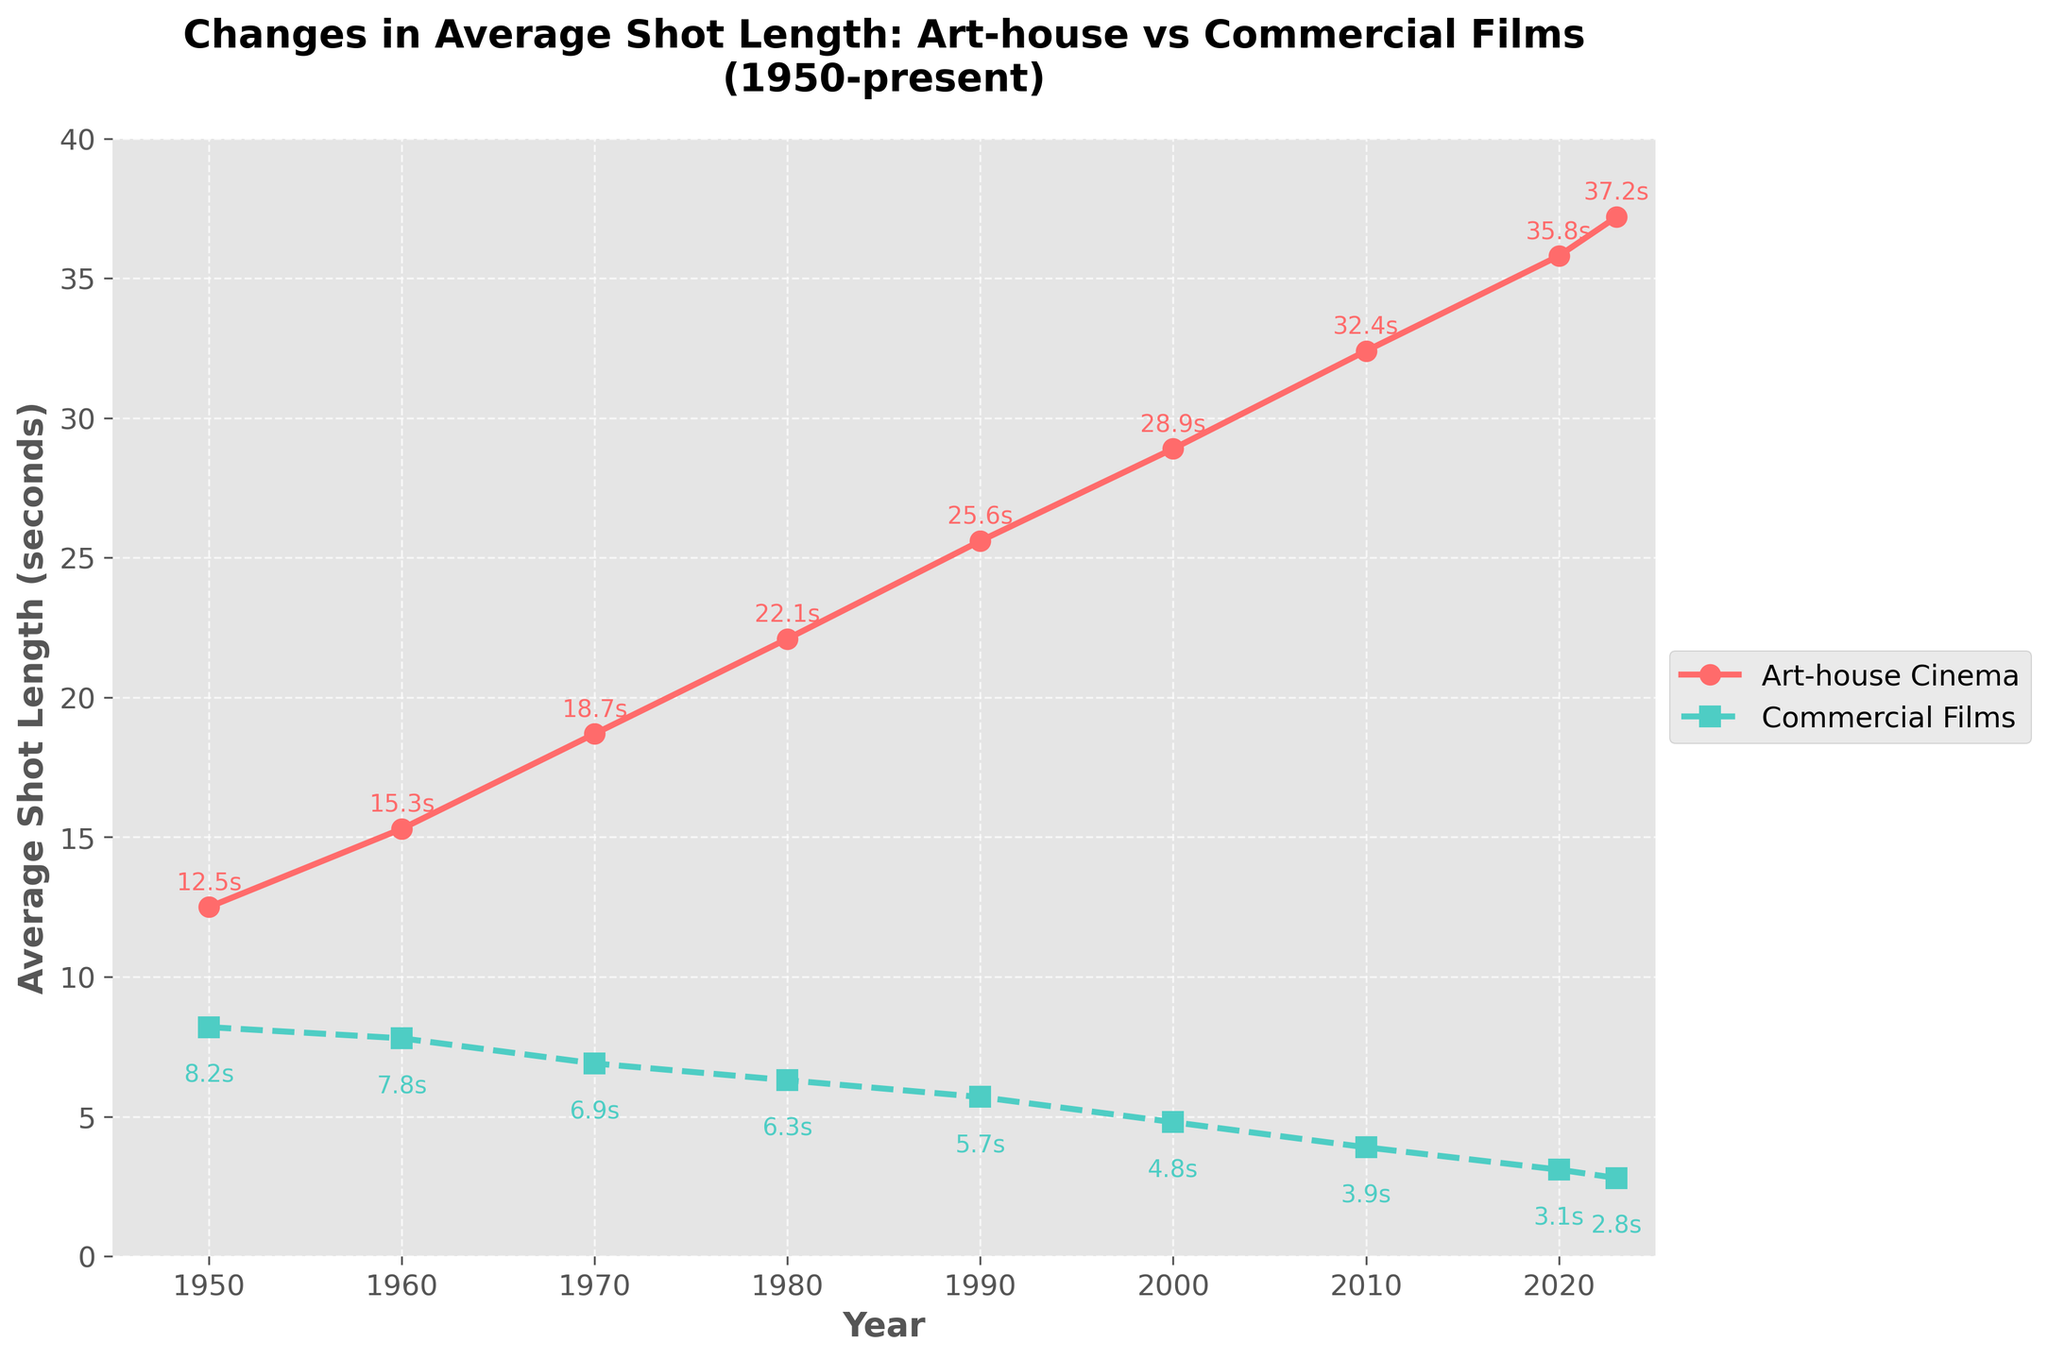Which year saw the biggest increase in average shot length for art-house cinema? By examining the increments, the biggest increase appears between 1960 and 1970, where the average shot length increases from 15.3 to 18.7 seconds, a jump of 3.4 seconds.
Answer: 1970 In 2023, how much shorter is the average shot length for commercial films compared to art-house cinema? In 2023, the shot length for commercial films is 2.8 seconds, and for art-house cinema, it is 37.2 seconds. The difference is 37.2 - 2.8 = 34.4 seconds.
Answer: 34.4 seconds What is the average shot length for commercial films over the entire period? Sum the shot lengths for commercial films (8.2 + 7.8 + 6.9 + 6.3 + 5.7 + 4.8 + 3.9 + 3.1 + 2.8) = 49.5. Divide by the number of years (9), the average is 49.5/9 ≈ 5.5 seconds.
Answer: 5.5 seconds Which period experienced the most significant rate of decrease in shot length for commercial films? Calculating the rate of decrease for each decade: 
1960-1950: (8.2-7.8)/10 ≈ 0.04 s/year 
1970-1960: (7.8-6.9)/10 ≈ 0.09 s/year 
1980-1970: (6.9-6.3)/10 ≈ 0.06 s/year
1990-1980: (6.3-5.7)/10 ≈ 0.06 s/year 
2000-1990: (5.7-4.8)/10 ≈ 0.09 s/year 
2010-2000: (4.8-3.9)/10 ≈ 0.09 s/year 
2020-2010: (3.9-3.1)/10 ≈ 0.08 s/year 
2023-2020: (3.1-2.8)/3 ≈ 0.1 s/year
The maximum rate of decrease occurs in 2023-2020 with approximately 0.1 s/year.
Answer: 2023-2020 Is the increase in average shot length for art-house cinema from 1950 to 2023 greater than the decrease for commercial films over the same period? The increase in art-house cinema from 1950 (12.5 seconds) to 2023 (37.2 seconds) is 37.2 - 12.5 = 24.7 seconds. The decrease for commercial films from 1950 (8.2 seconds) to 2023 (2.8 seconds) is 8.2 - 2.8 = 5.4 seconds. The increase for art-house cinema is greater.
Answer: Yes What's the average increase in shot length for art-house cinema per decade? Total increase from 1950 to 2023 is 37.2 - 12.5 = 24.7 seconds. Divide by the number of decades (7.3 decades): 24.7 / 7.3 ≈ 3.38 seconds/decade.
Answer: ≈ 3.38 seconds/decade What year did the average shot length for art-house cinema first exceed 20 seconds? In the year 1980, the average shot length for art-house cinema was 22.1 seconds, which is the first year it exceeded 20 seconds.
Answer: 1980 Which category has the greatest range in shot lengths over the period? The range for art-house cinema is 37.2 - 12.5 = 24.7 seconds. The range for commercial films is 8.2 - 2.8 = 5.4 seconds. Art-house cinema has the greatest range.
Answer: Art-house cinema 